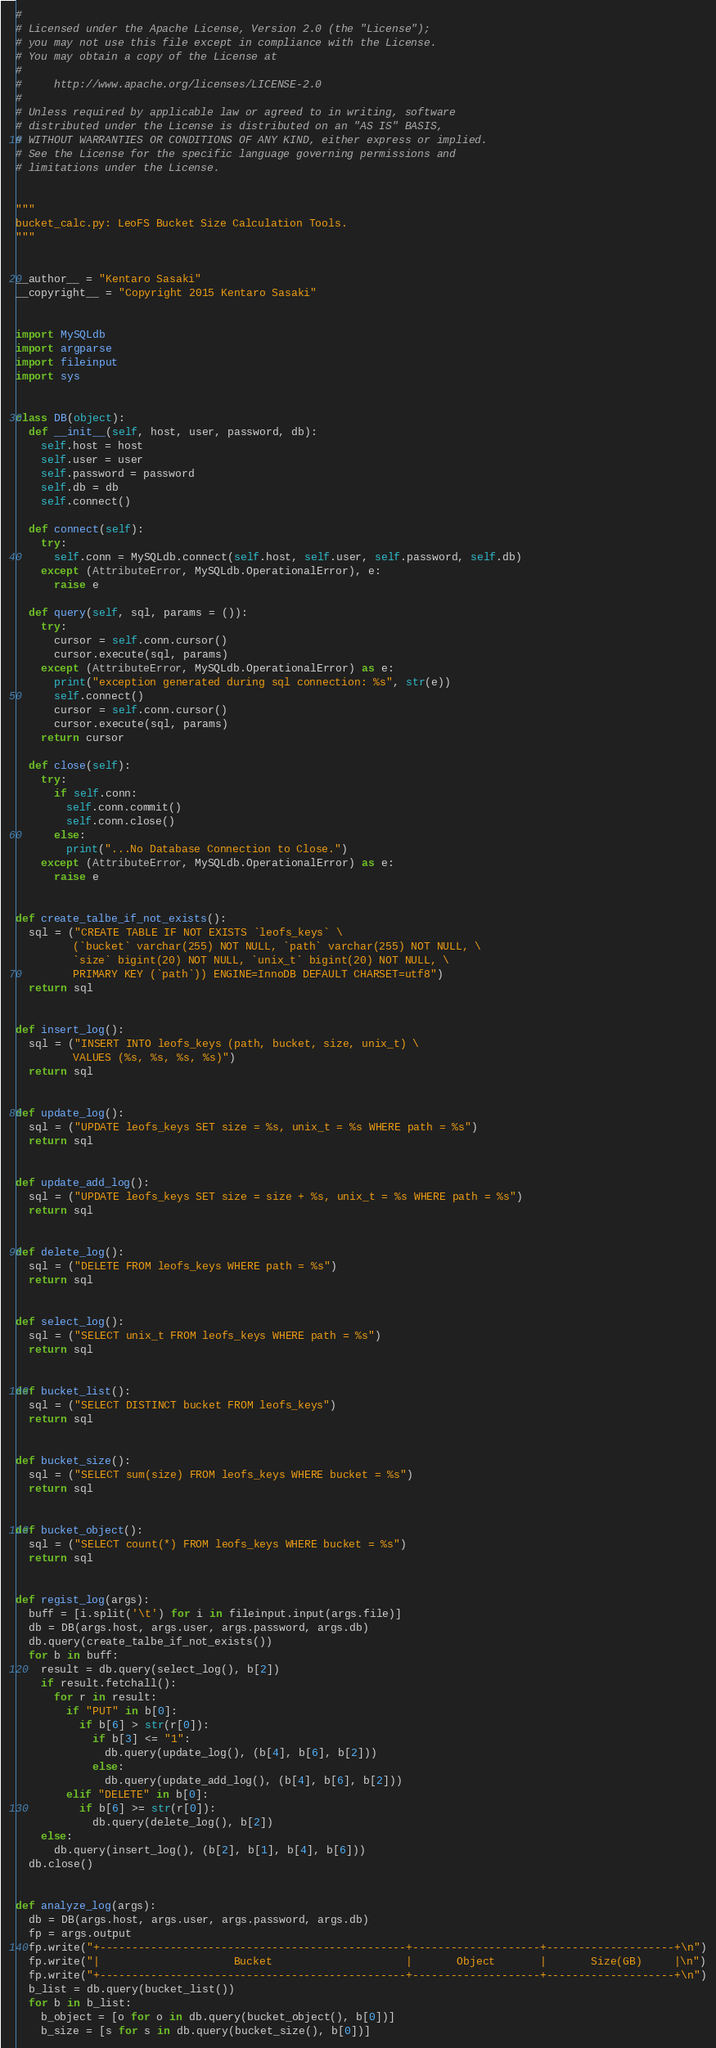Convert code to text. <code><loc_0><loc_0><loc_500><loc_500><_Python_>#
# Licensed under the Apache License, Version 2.0 (the "License");
# you may not use this file except in compliance with the License.
# You may obtain a copy of the License at
#
#     http://www.apache.org/licenses/LICENSE-2.0
#
# Unless required by applicable law or agreed to in writing, software
# distributed under the License is distributed on an "AS IS" BASIS,
# WITHOUT WARRANTIES OR CONDITIONS OF ANY KIND, either express or implied.
# See the License for the specific language governing permissions and
# limitations under the License.


"""
bucket_calc.py: LeoFS Bucket Size Calculation Tools.
"""


__author__ = "Kentaro Sasaki"
__copyright__ = "Copyright 2015 Kentaro Sasaki"


import MySQLdb
import argparse
import fileinput
import sys


class DB(object):
  def __init__(self, host, user, password, db):
    self.host = host
    self.user = user
    self.password = password
    self.db = db
    self.connect()

  def connect(self):
    try:
      self.conn = MySQLdb.connect(self.host, self.user, self.password, self.db)
    except (AttributeError, MySQLdb.OperationalError), e:
      raise e

  def query(self, sql, params = ()):
    try:
      cursor = self.conn.cursor()
      cursor.execute(sql, params)
    except (AttributeError, MySQLdb.OperationalError) as e:
      print("exception generated during sql connection: %s", str(e))
      self.connect()
      cursor = self.conn.cursor()
      cursor.execute(sql, params)
    return cursor

  def close(self):
    try:
      if self.conn:
        self.conn.commit()
        self.conn.close()
      else:
        print("...No Database Connection to Close.")
    except (AttributeError, MySQLdb.OperationalError) as e:
      raise e


def create_talbe_if_not_exists():
  sql = ("CREATE TABLE IF NOT EXISTS `leofs_keys` \
         (`bucket` varchar(255) NOT NULL, `path` varchar(255) NOT NULL, \
         `size` bigint(20) NOT NULL, `unix_t` bigint(20) NOT NULL, \
         PRIMARY KEY (`path`)) ENGINE=InnoDB DEFAULT CHARSET=utf8")
  return sql


def insert_log():
  sql = ("INSERT INTO leofs_keys (path, bucket, size, unix_t) \
         VALUES (%s, %s, %s, %s)")
  return sql


def update_log():
  sql = ("UPDATE leofs_keys SET size = %s, unix_t = %s WHERE path = %s")
  return sql


def update_add_log():
  sql = ("UPDATE leofs_keys SET size = size + %s, unix_t = %s WHERE path = %s")
  return sql


def delete_log():
  sql = ("DELETE FROM leofs_keys WHERE path = %s")
  return sql


def select_log():
  sql = ("SELECT unix_t FROM leofs_keys WHERE path = %s")
  return sql


def bucket_list():
  sql = ("SELECT DISTINCT bucket FROM leofs_keys")
  return sql


def bucket_size():
  sql = ("SELECT sum(size) FROM leofs_keys WHERE bucket = %s")
  return sql


def bucket_object():
  sql = ("SELECT count(*) FROM leofs_keys WHERE bucket = %s")
  return sql


def regist_log(args):
  buff = [i.split('\t') for i in fileinput.input(args.file)]
  db = DB(args.host, args.user, args.password, args.db)
  db.query(create_talbe_if_not_exists())
  for b in buff:
    result = db.query(select_log(), b[2])
    if result.fetchall():
      for r in result:
        if "PUT" in b[0]:
          if b[6] > str(r[0]):
            if b[3] <= "1":
              db.query(update_log(), (b[4], b[6], b[2]))
            else:
              db.query(update_add_log(), (b[4], b[6], b[2]))
        elif "DELETE" in b[0]:
          if b[6] >= str(r[0]):
            db.query(delete_log(), b[2])
    else:
      db.query(insert_log(), (b[2], b[1], b[4], b[6]))
  db.close()


def analyze_log(args):
  db = DB(args.host, args.user, args.password, args.db)
  fp = args.output
  fp.write("+------------------------------------------------+--------------------+--------------------+\n")
  fp.write("|                     Bucket                     |       Object       |       Size(GB)     |\n")
  fp.write("+------------------------------------------------+--------------------+--------------------+\n")
  b_list = db.query(bucket_list())
  for b in b_list:
    b_object = [o for o in db.query(bucket_object(), b[0])]
    b_size = [s for s in db.query(bucket_size(), b[0])]</code> 